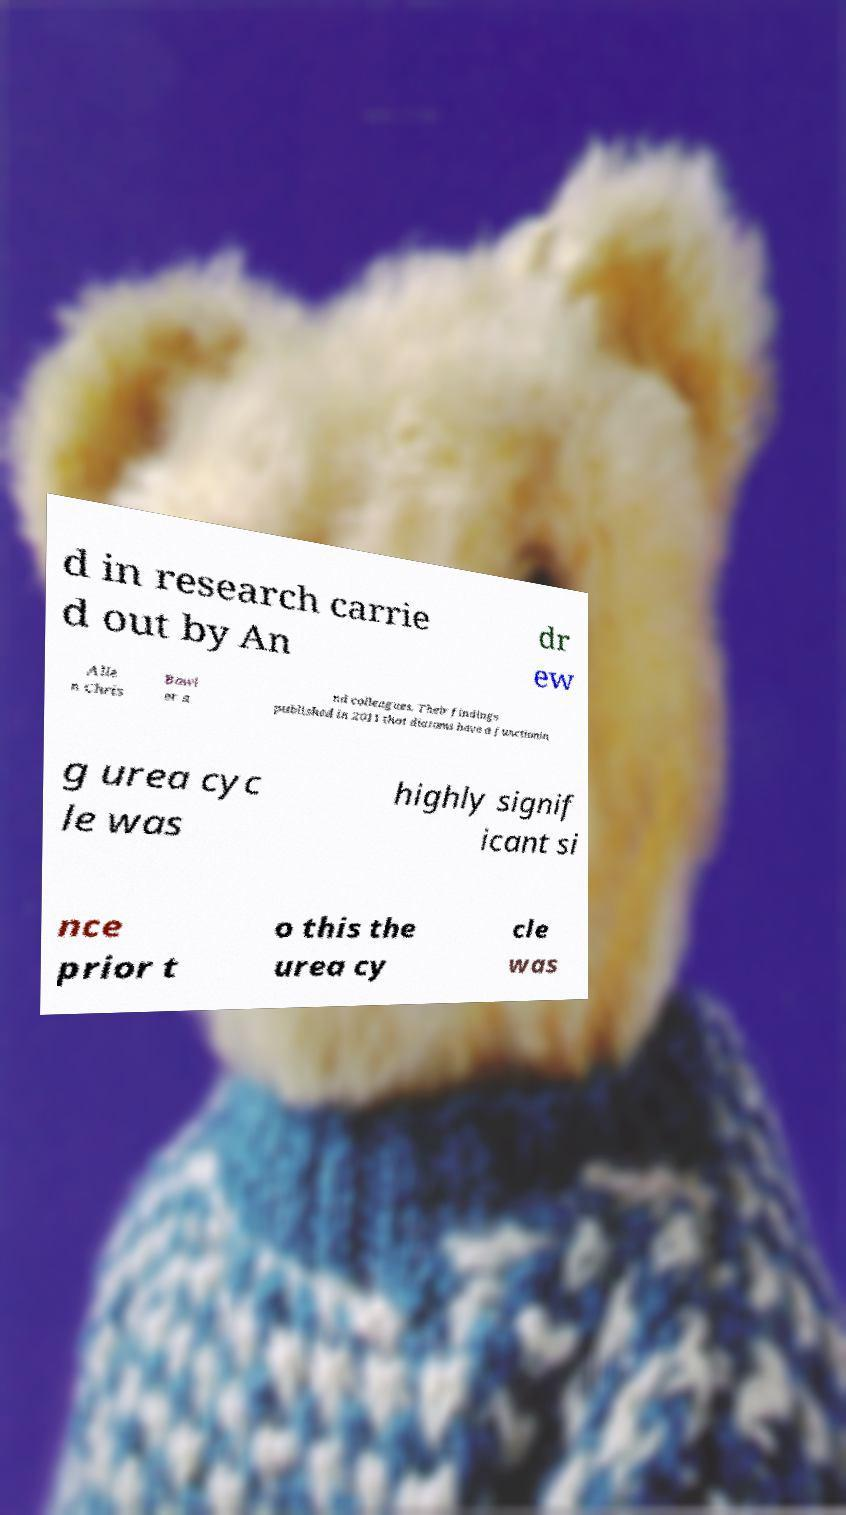Could you extract and type out the text from this image? d in research carrie d out by An dr ew Alle n Chris Bowl er a nd colleagues. Their findings published in 2011 that diatoms have a functionin g urea cyc le was highly signif icant si nce prior t o this the urea cy cle was 